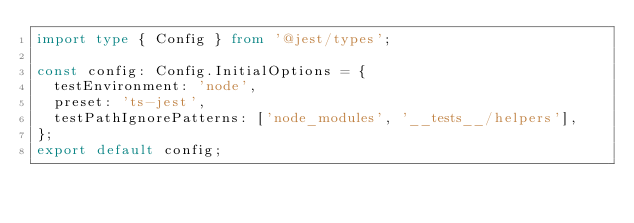<code> <loc_0><loc_0><loc_500><loc_500><_TypeScript_>import type { Config } from '@jest/types';

const config: Config.InitialOptions = {
  testEnvironment: 'node',
  preset: 'ts-jest',
  testPathIgnorePatterns: ['node_modules', '__tests__/helpers'],
};
export default config;</code> 